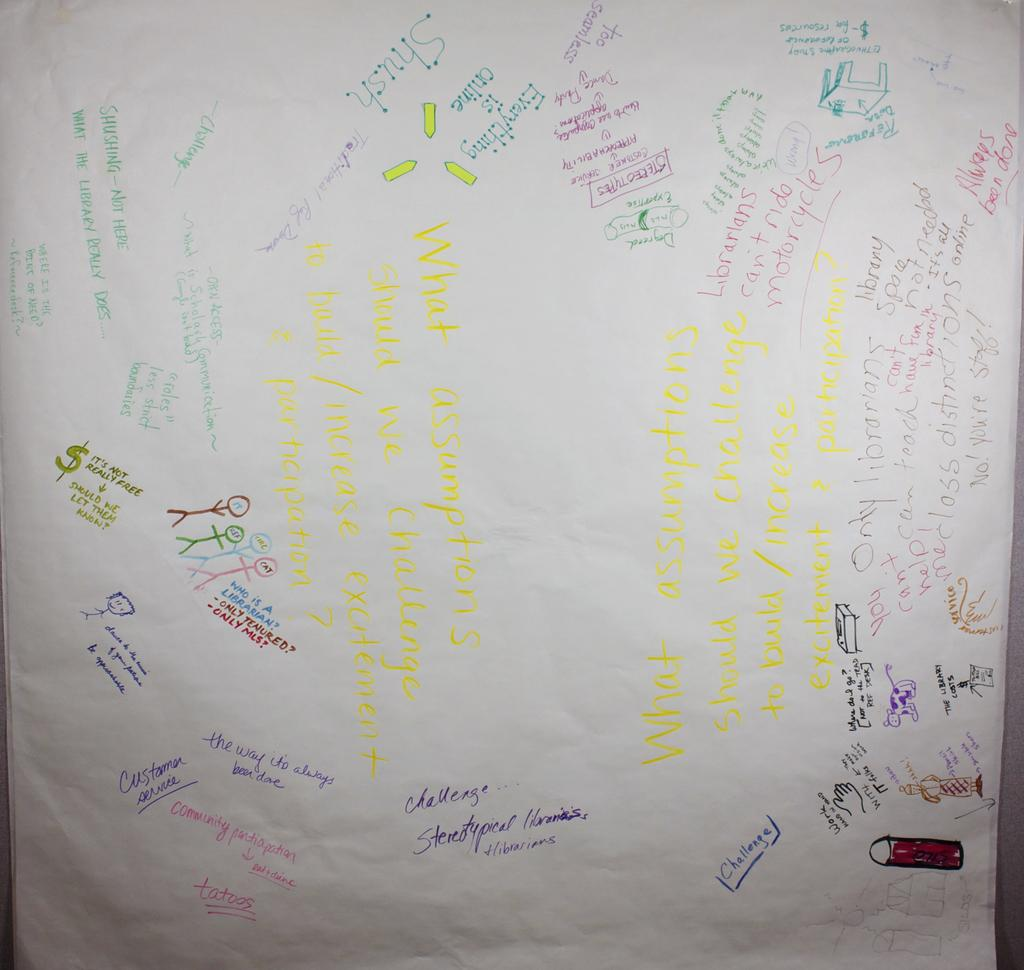Provide a one-sentence caption for the provided image. A paper sign with different sayings says to work hand in hand. 